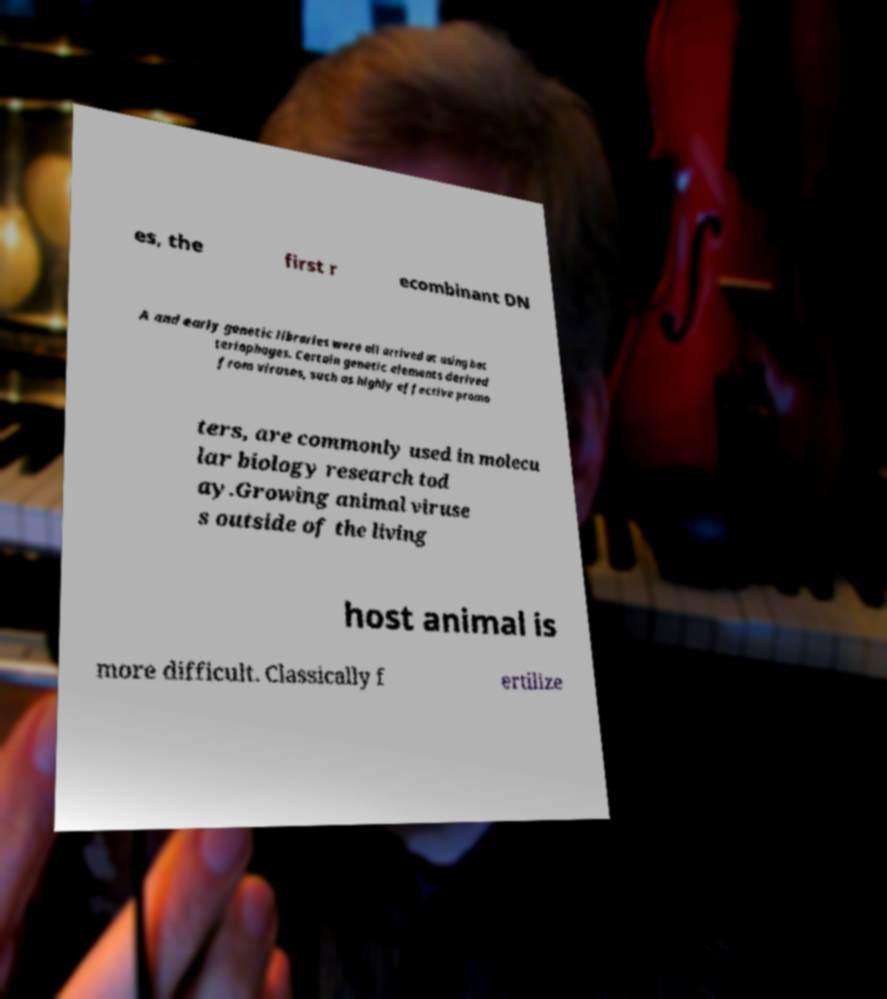Please read and relay the text visible in this image. What does it say? es, the first r ecombinant DN A and early genetic libraries were all arrived at using bac teriophages. Certain genetic elements derived from viruses, such as highly effective promo ters, are commonly used in molecu lar biology research tod ay.Growing animal viruse s outside of the living host animal is more difficult. Classically f ertilize 